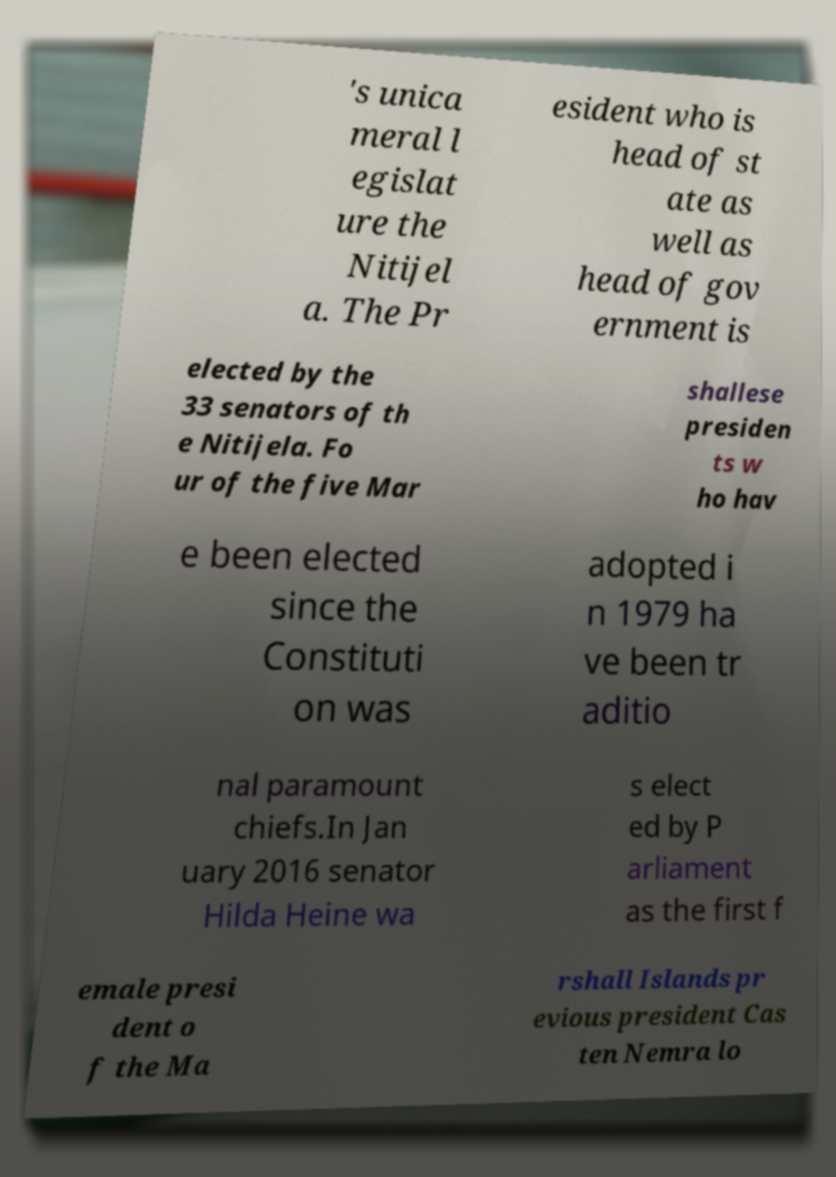For documentation purposes, I need the text within this image transcribed. Could you provide that? 's unica meral l egislat ure the Nitijel a. The Pr esident who is head of st ate as well as head of gov ernment is elected by the 33 senators of th e Nitijela. Fo ur of the five Mar shallese presiden ts w ho hav e been elected since the Constituti on was adopted i n 1979 ha ve been tr aditio nal paramount chiefs.In Jan uary 2016 senator Hilda Heine wa s elect ed by P arliament as the first f emale presi dent o f the Ma rshall Islands pr evious president Cas ten Nemra lo 